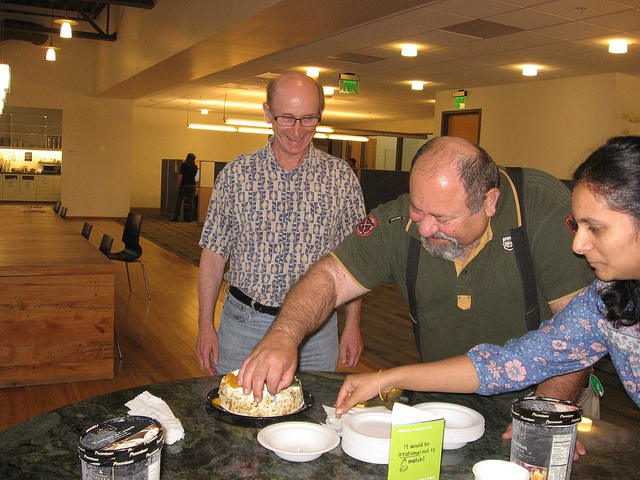Describe the objects in this image and their specific colors. I can see people in black, brown, and salmon tones, dining table in black, gray, and lightgray tones, people in black, gray, darkgray, brown, and tan tones, people in black, tan, and gray tones, and dining table in black, maroon, and brown tones in this image. 